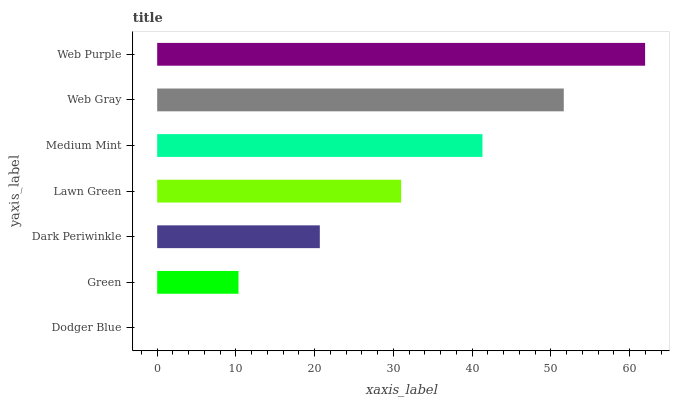Is Dodger Blue the minimum?
Answer yes or no. Yes. Is Web Purple the maximum?
Answer yes or no. Yes. Is Green the minimum?
Answer yes or no. No. Is Green the maximum?
Answer yes or no. No. Is Green greater than Dodger Blue?
Answer yes or no. Yes. Is Dodger Blue less than Green?
Answer yes or no. Yes. Is Dodger Blue greater than Green?
Answer yes or no. No. Is Green less than Dodger Blue?
Answer yes or no. No. Is Lawn Green the high median?
Answer yes or no. Yes. Is Lawn Green the low median?
Answer yes or no. Yes. Is Medium Mint the high median?
Answer yes or no. No. Is Green the low median?
Answer yes or no. No. 